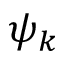Convert formula to latex. <formula><loc_0><loc_0><loc_500><loc_500>\psi _ { k }</formula> 